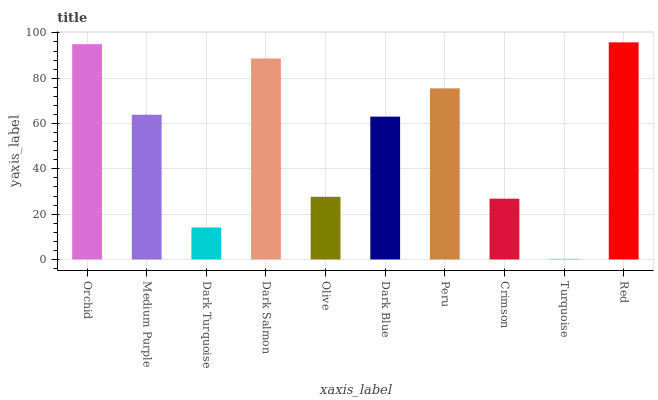Is Turquoise the minimum?
Answer yes or no. Yes. Is Red the maximum?
Answer yes or no. Yes. Is Medium Purple the minimum?
Answer yes or no. No. Is Medium Purple the maximum?
Answer yes or no. No. Is Orchid greater than Medium Purple?
Answer yes or no. Yes. Is Medium Purple less than Orchid?
Answer yes or no. Yes. Is Medium Purple greater than Orchid?
Answer yes or no. No. Is Orchid less than Medium Purple?
Answer yes or no. No. Is Medium Purple the high median?
Answer yes or no. Yes. Is Dark Blue the low median?
Answer yes or no. Yes. Is Dark Salmon the high median?
Answer yes or no. No. Is Orchid the low median?
Answer yes or no. No. 